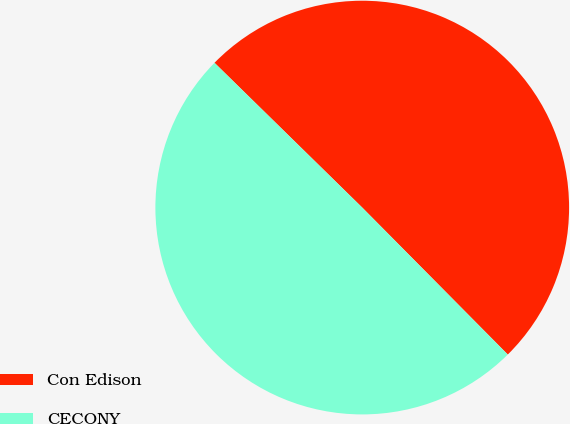Convert chart. <chart><loc_0><loc_0><loc_500><loc_500><pie_chart><fcel>Con Edison<fcel>CECONY<nl><fcel>50.24%<fcel>49.76%<nl></chart> 